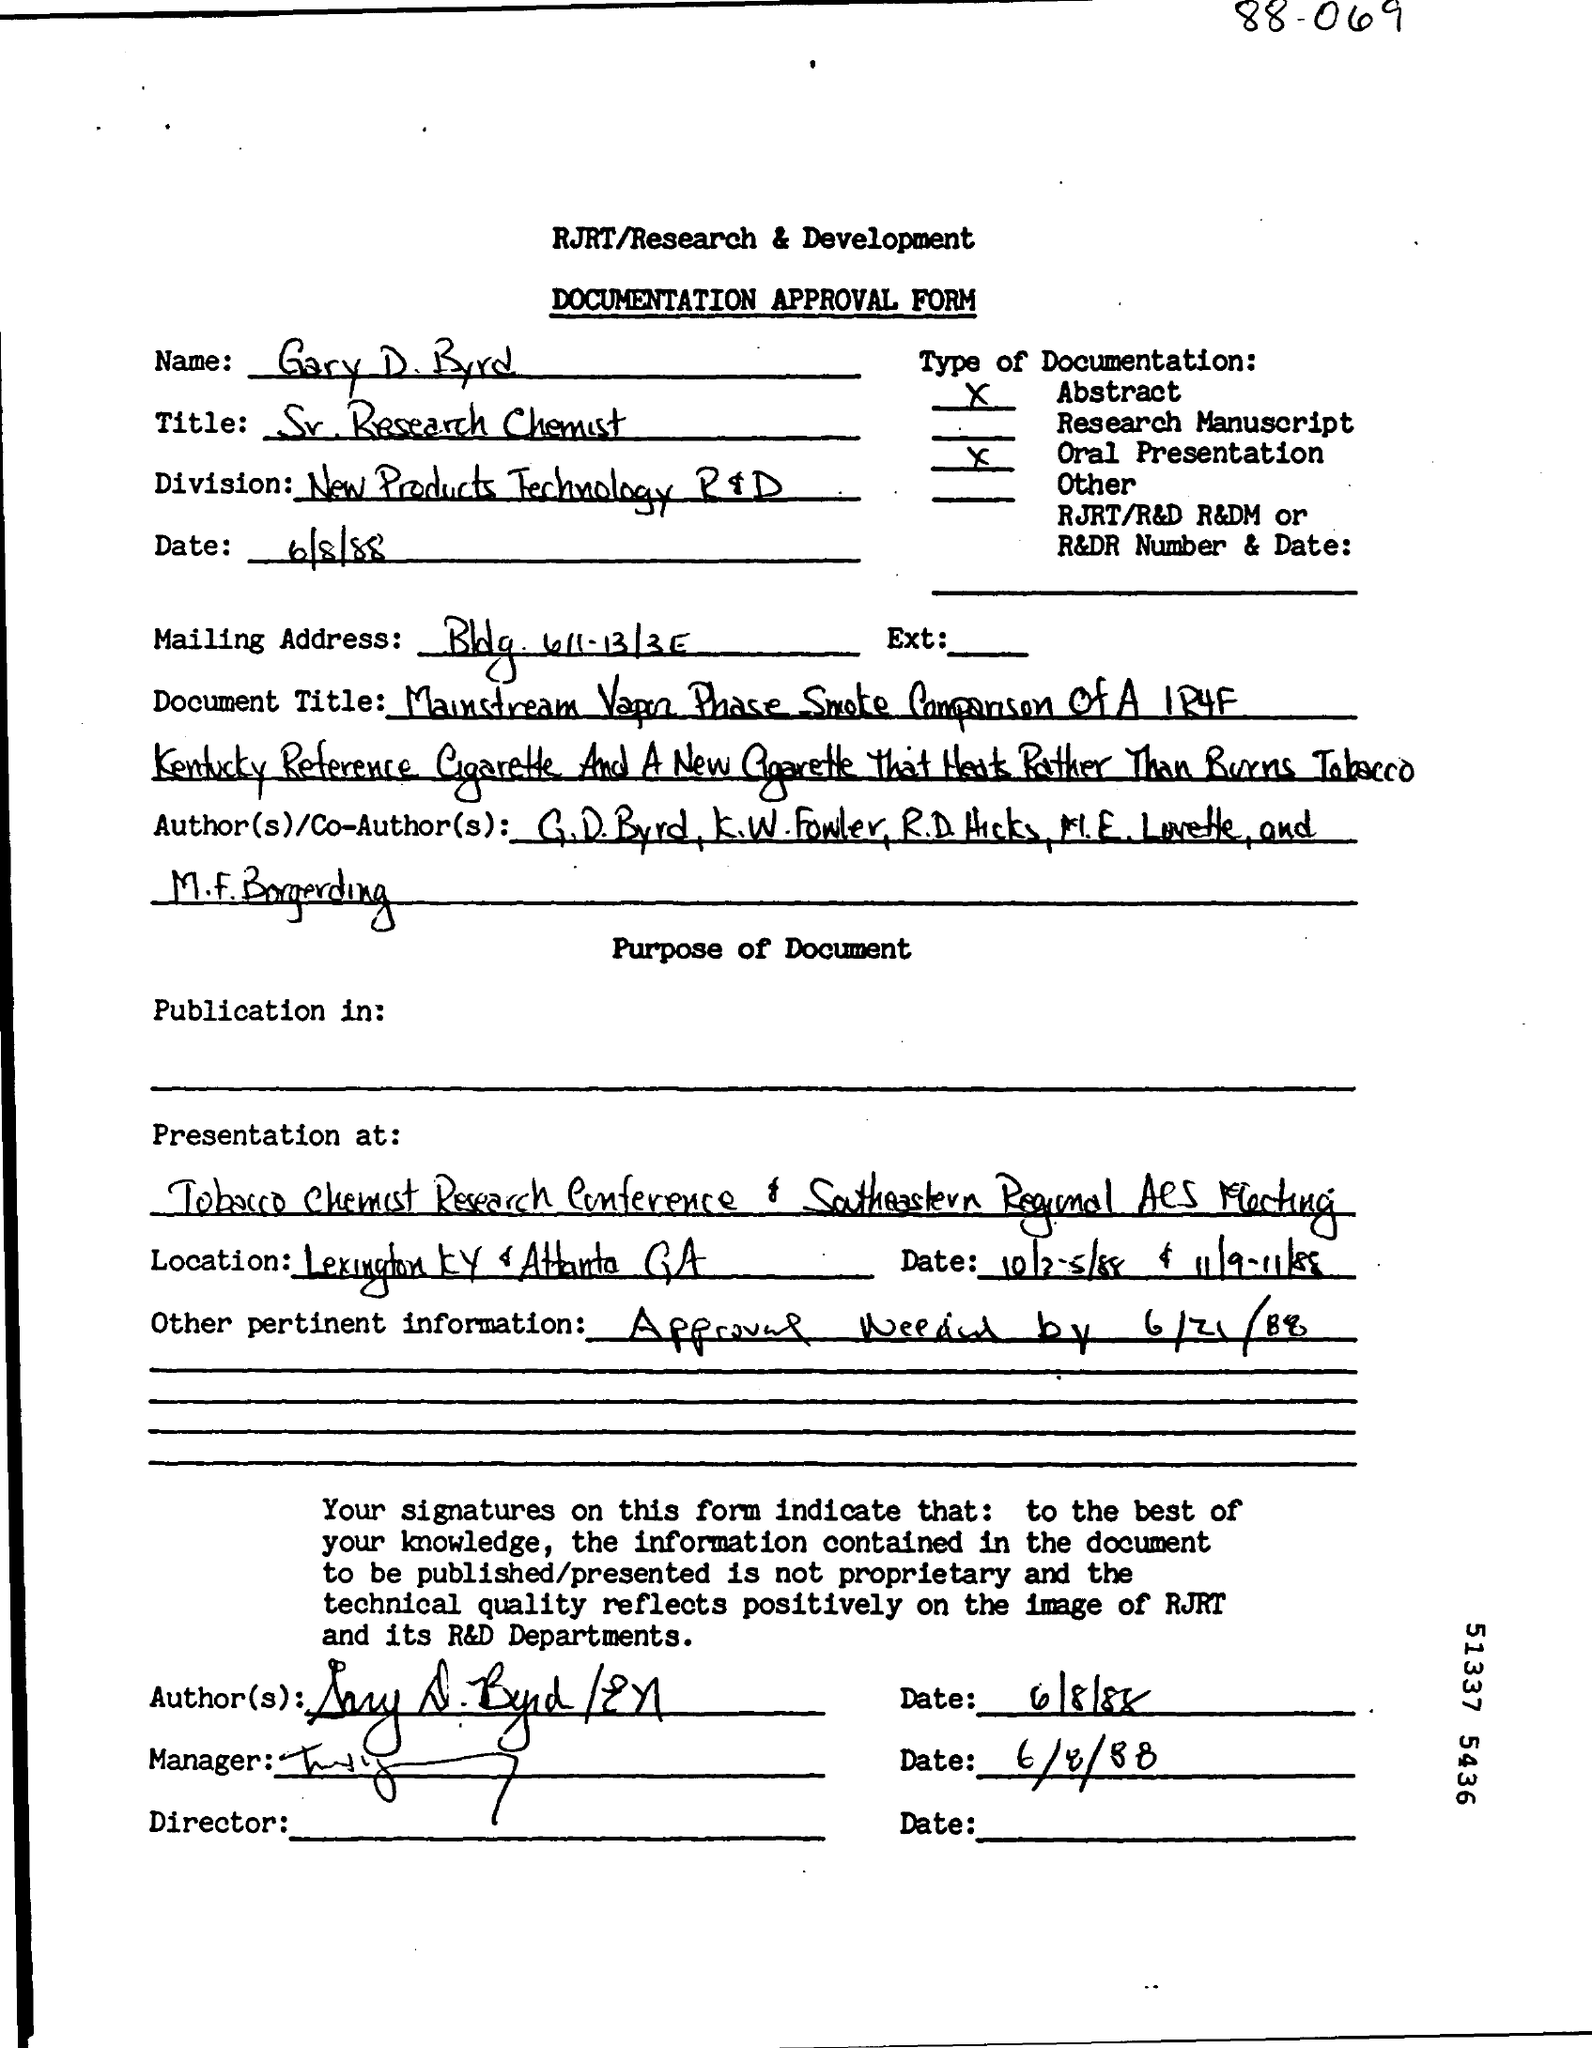Mention a couple of crucial points in this snapshot. The documentation approval form is a type of form. Gary D. Byrd is a senior research chemist. The information provided includes a deadline for approval of June 21, 1988. The name given is Gary D. Byrd. 